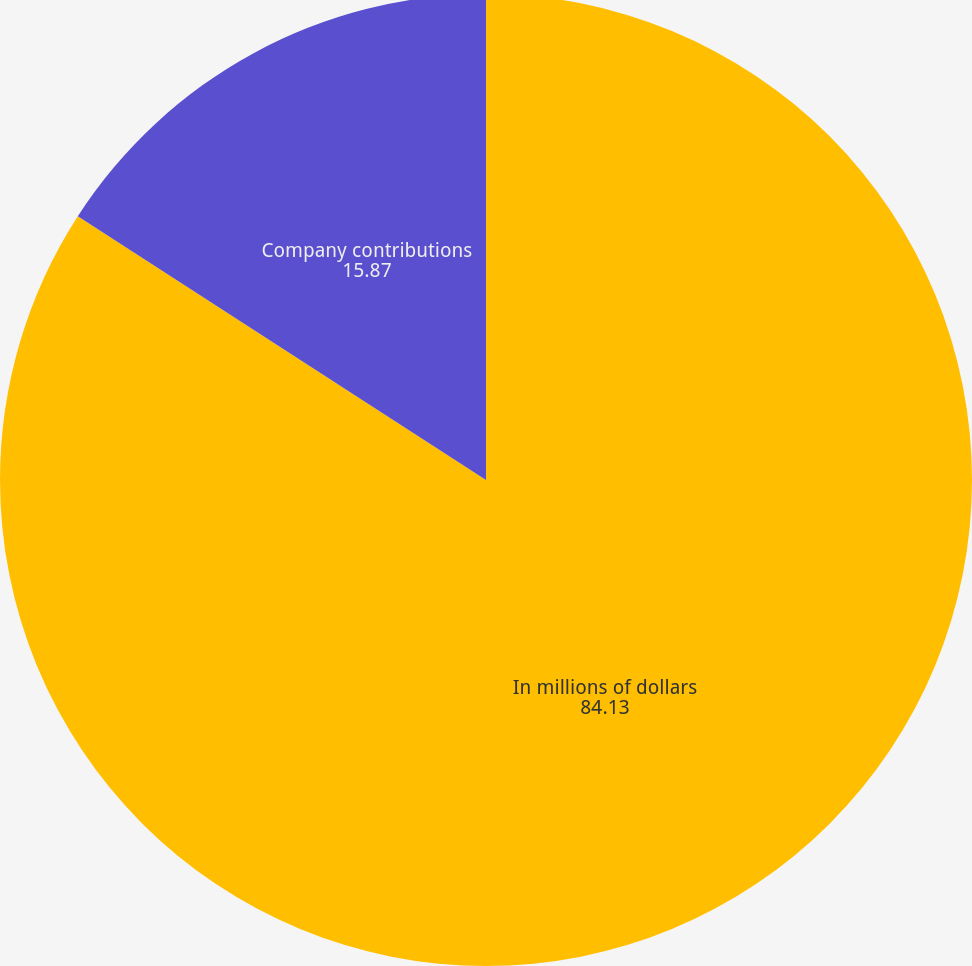Convert chart to OTSL. <chart><loc_0><loc_0><loc_500><loc_500><pie_chart><fcel>In millions of dollars<fcel>Company contributions<nl><fcel>84.13%<fcel>15.87%<nl></chart> 